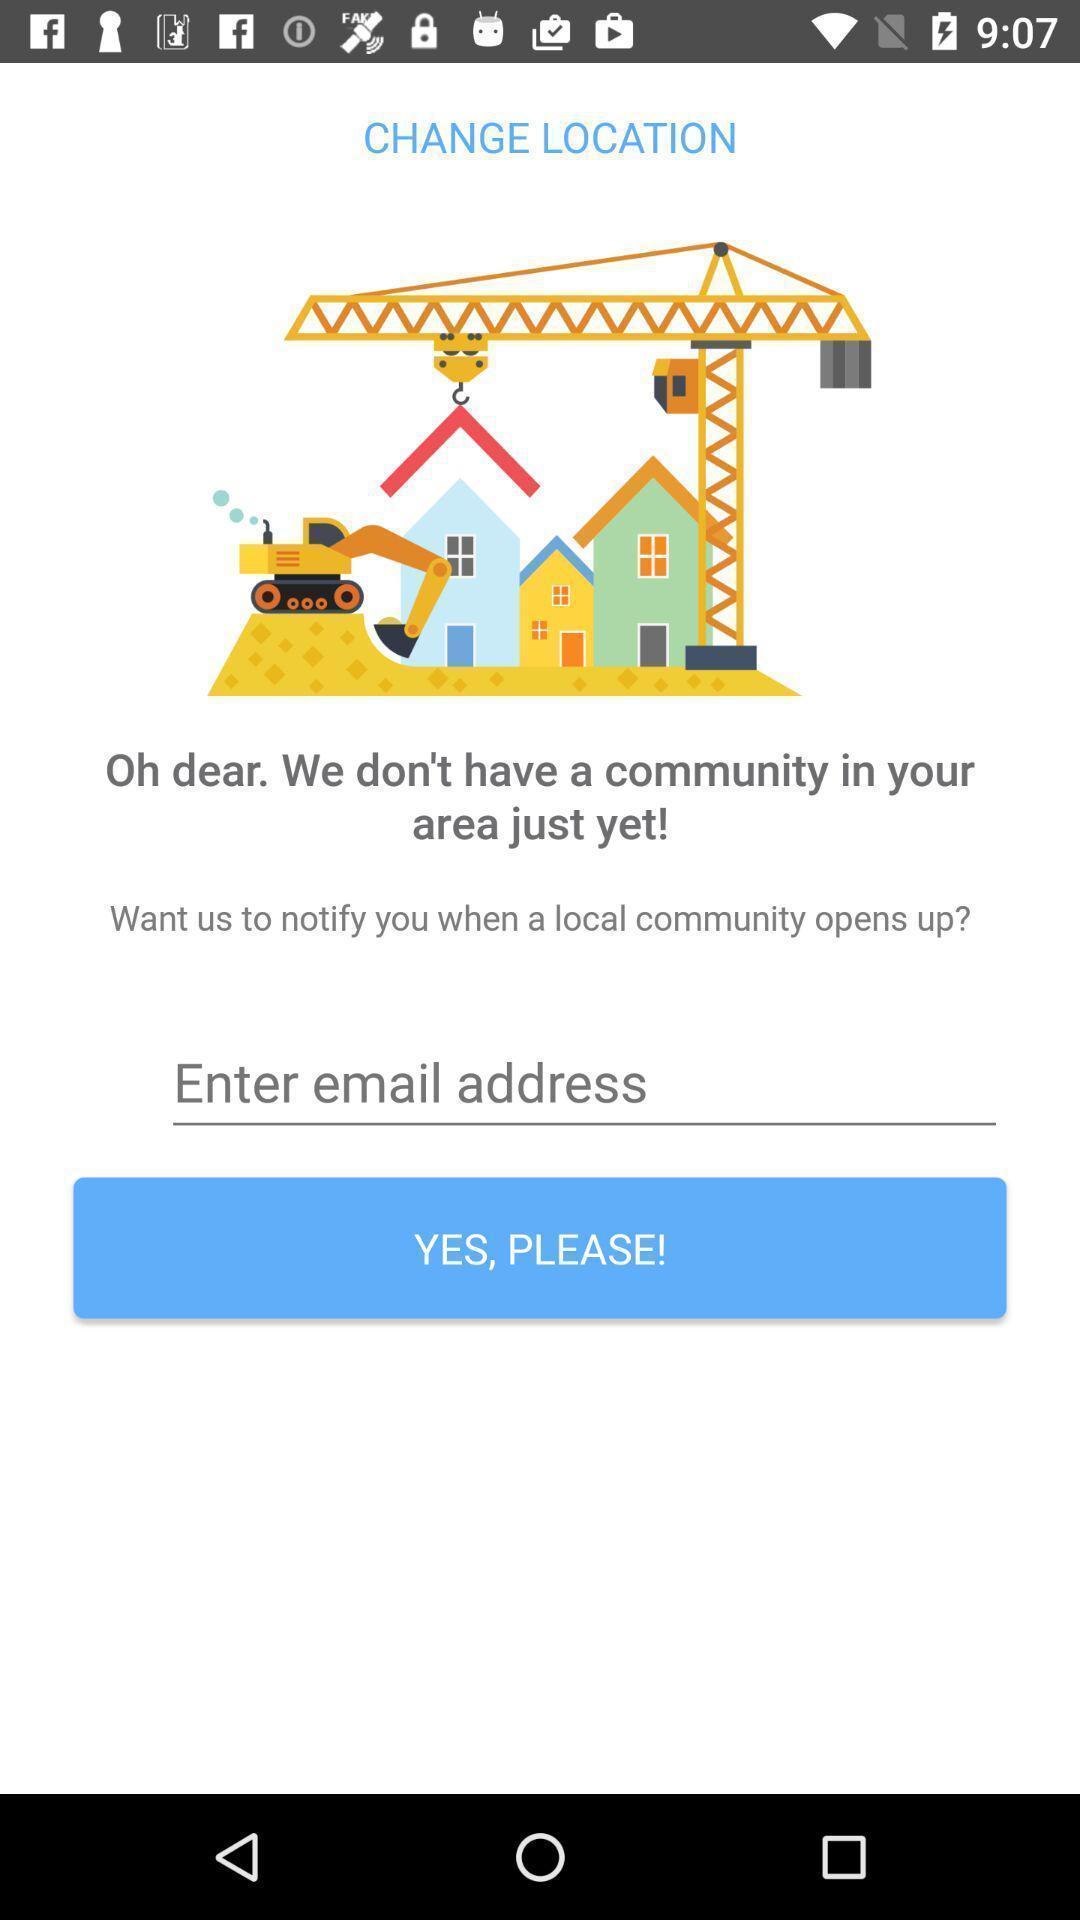Provide a description of this screenshot. Page displaying the enter a email. 